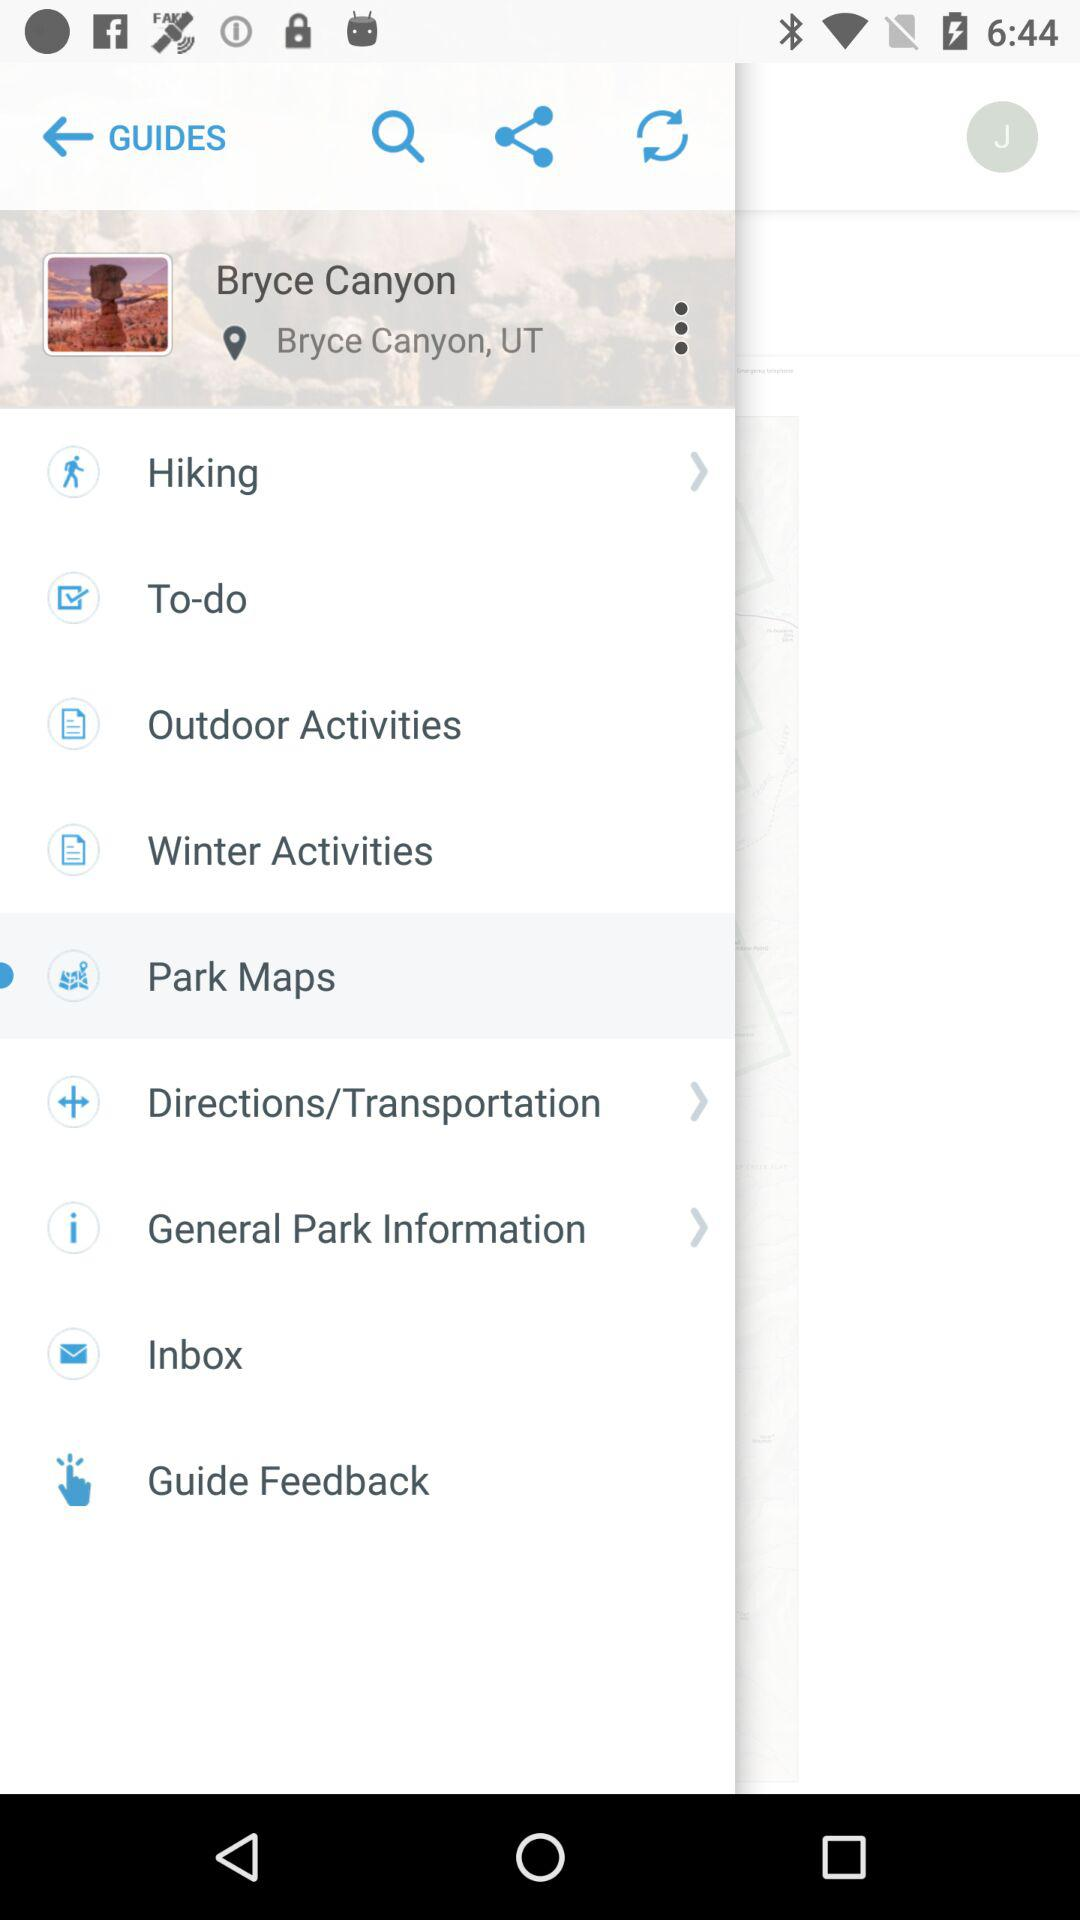What is the location? The location is Bryce Canyon, UT. 